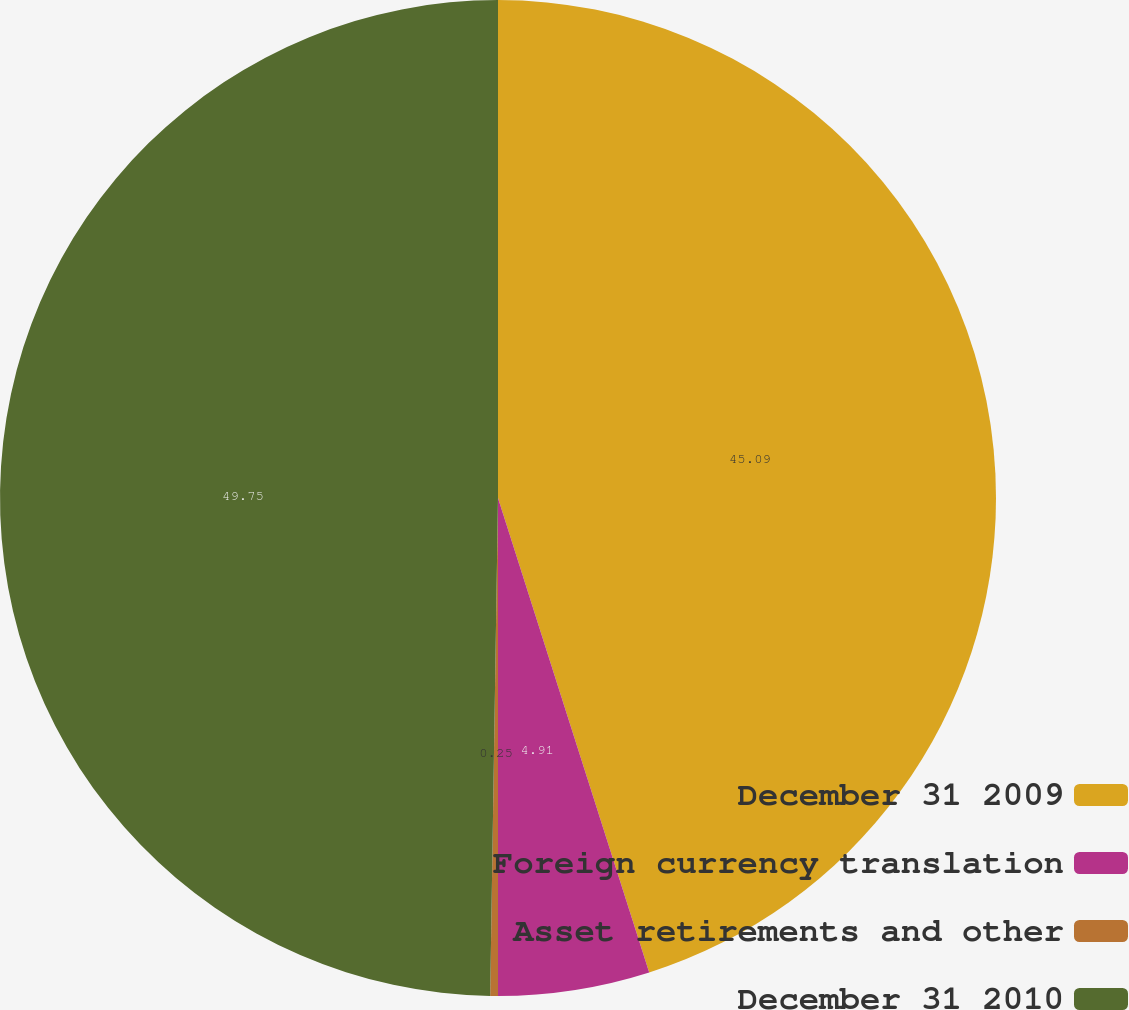<chart> <loc_0><loc_0><loc_500><loc_500><pie_chart><fcel>December 31 2009<fcel>Foreign currency translation<fcel>Asset retirements and other<fcel>December 31 2010<nl><fcel>45.09%<fcel>4.91%<fcel>0.25%<fcel>49.75%<nl></chart> 